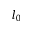<formula> <loc_0><loc_0><loc_500><loc_500>l _ { 0 }</formula> 